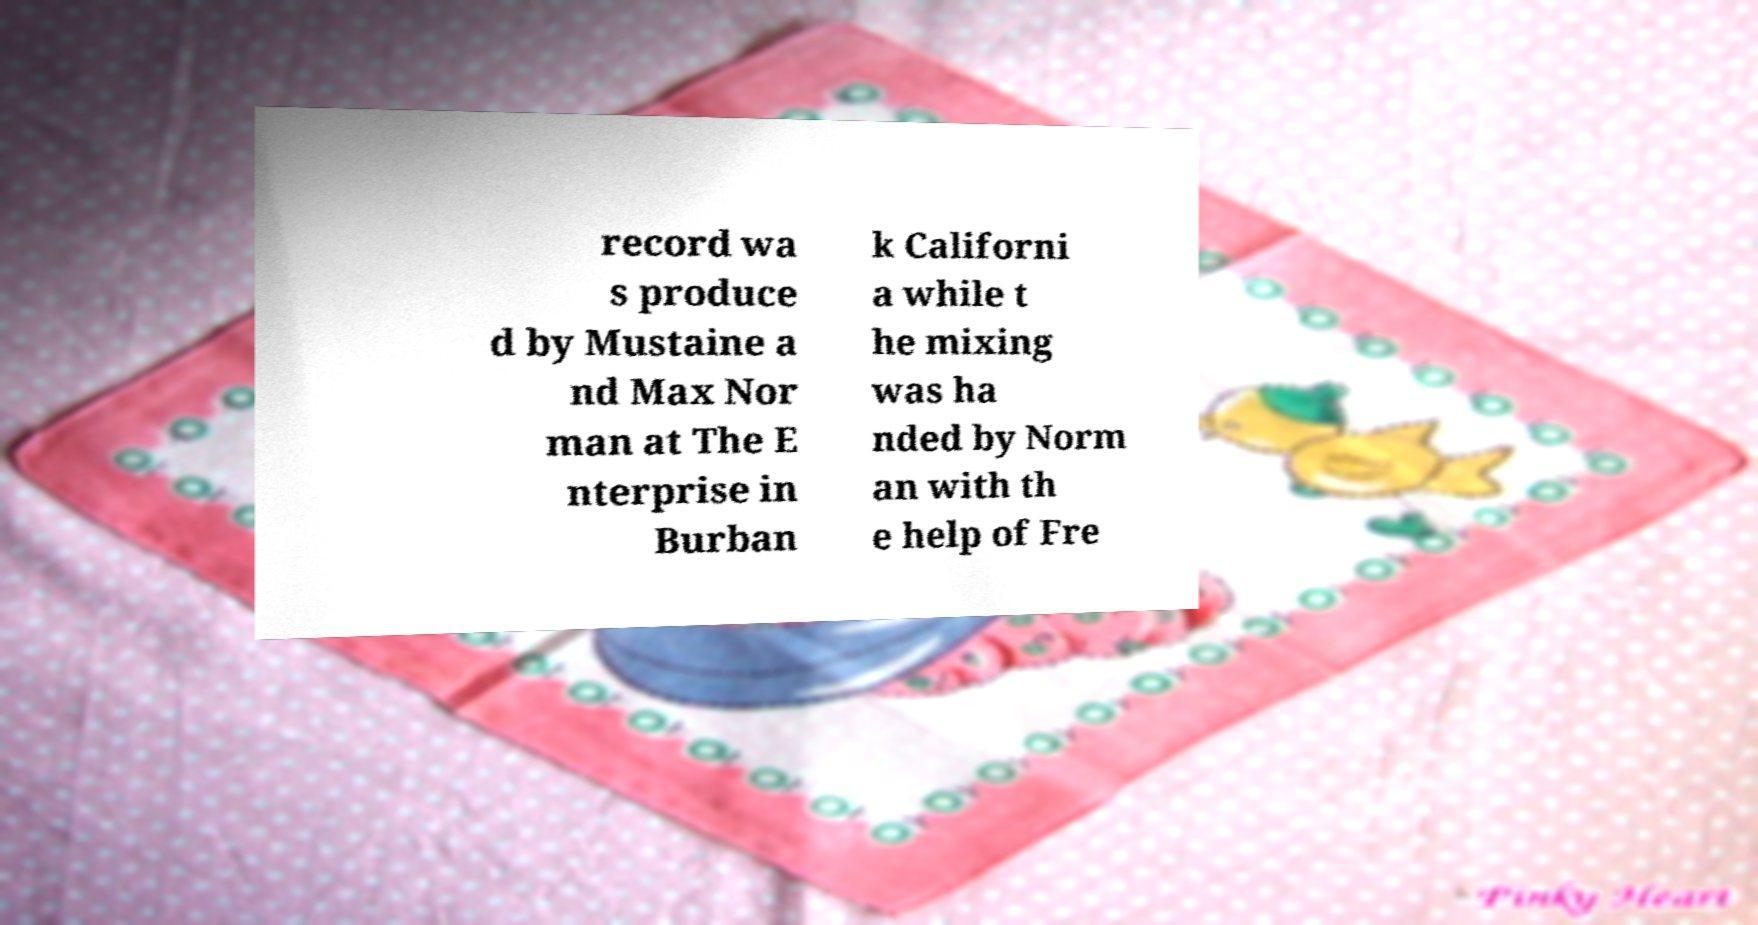Could you assist in decoding the text presented in this image and type it out clearly? record wa s produce d by Mustaine a nd Max Nor man at The E nterprise in Burban k Californi a while t he mixing was ha nded by Norm an with th e help of Fre 